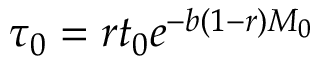<formula> <loc_0><loc_0><loc_500><loc_500>\tau _ { 0 } = r t _ { 0 } e ^ { - b ( 1 - r ) M _ { 0 } }</formula> 